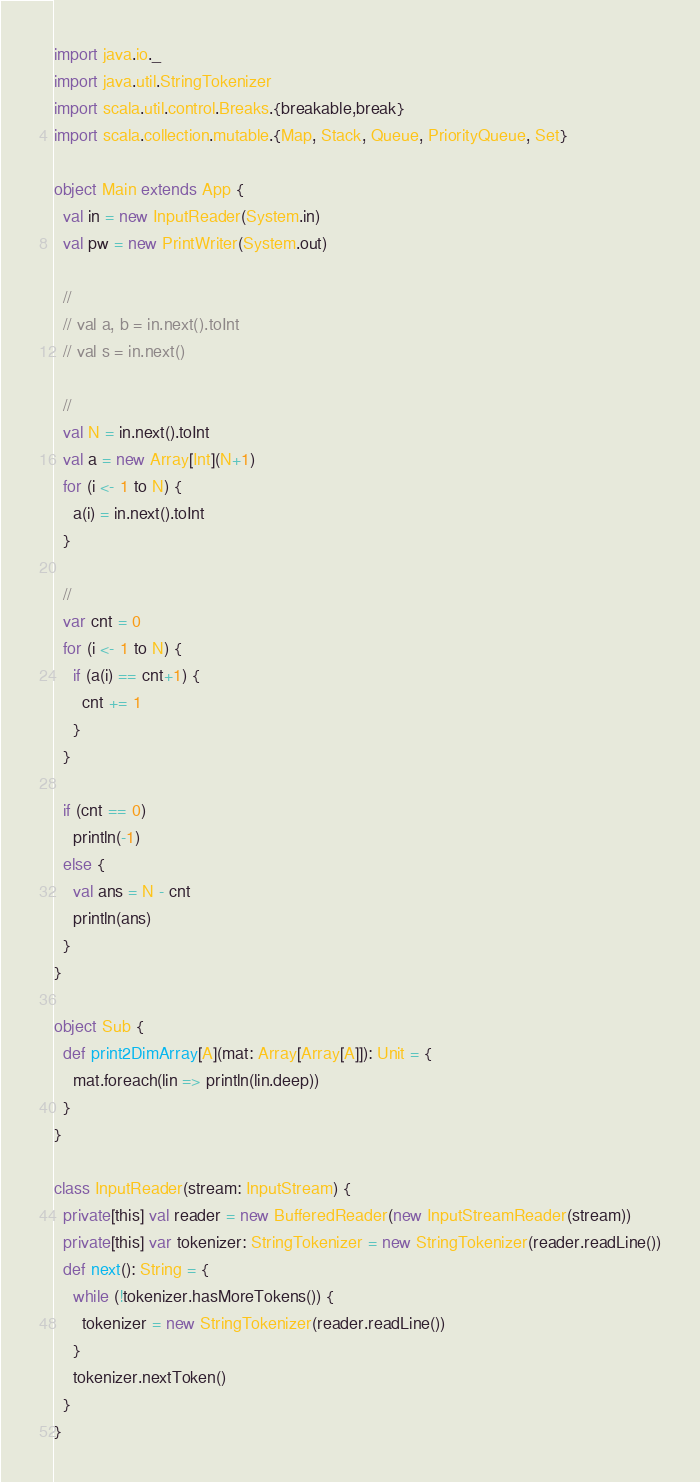<code> <loc_0><loc_0><loc_500><loc_500><_Scala_>import java.io._
import java.util.StringTokenizer
import scala.util.control.Breaks.{breakable,break}
import scala.collection.mutable.{Map, Stack, Queue, PriorityQueue, Set}

object Main extends App {
  val in = new InputReader(System.in)
  val pw = new PrintWriter(System.out)

  // 
  // val a, b = in.next().toInt
  // val s = in.next()

  //
  val N = in.next().toInt
  val a = new Array[Int](N+1)
  for (i <- 1 to N) {
    a(i) = in.next().toInt
  }

  //
  var cnt = 0
  for (i <- 1 to N) {
    if (a(i) == cnt+1) {
      cnt += 1
    }
  }

  if (cnt == 0)
    println(-1)
  else {
    val ans = N - cnt
    println(ans)
  }
}

object Sub {
  def print2DimArray[A](mat: Array[Array[A]]): Unit = {
    mat.foreach(lin => println(lin.deep))
  }
}

class InputReader(stream: InputStream) {
  private[this] val reader = new BufferedReader(new InputStreamReader(stream))
  private[this] var tokenizer: StringTokenizer = new StringTokenizer(reader.readLine())
  def next(): String = {
    while (!tokenizer.hasMoreTokens()) {
      tokenizer = new StringTokenizer(reader.readLine())
    }
    tokenizer.nextToken()
  }
}
</code> 